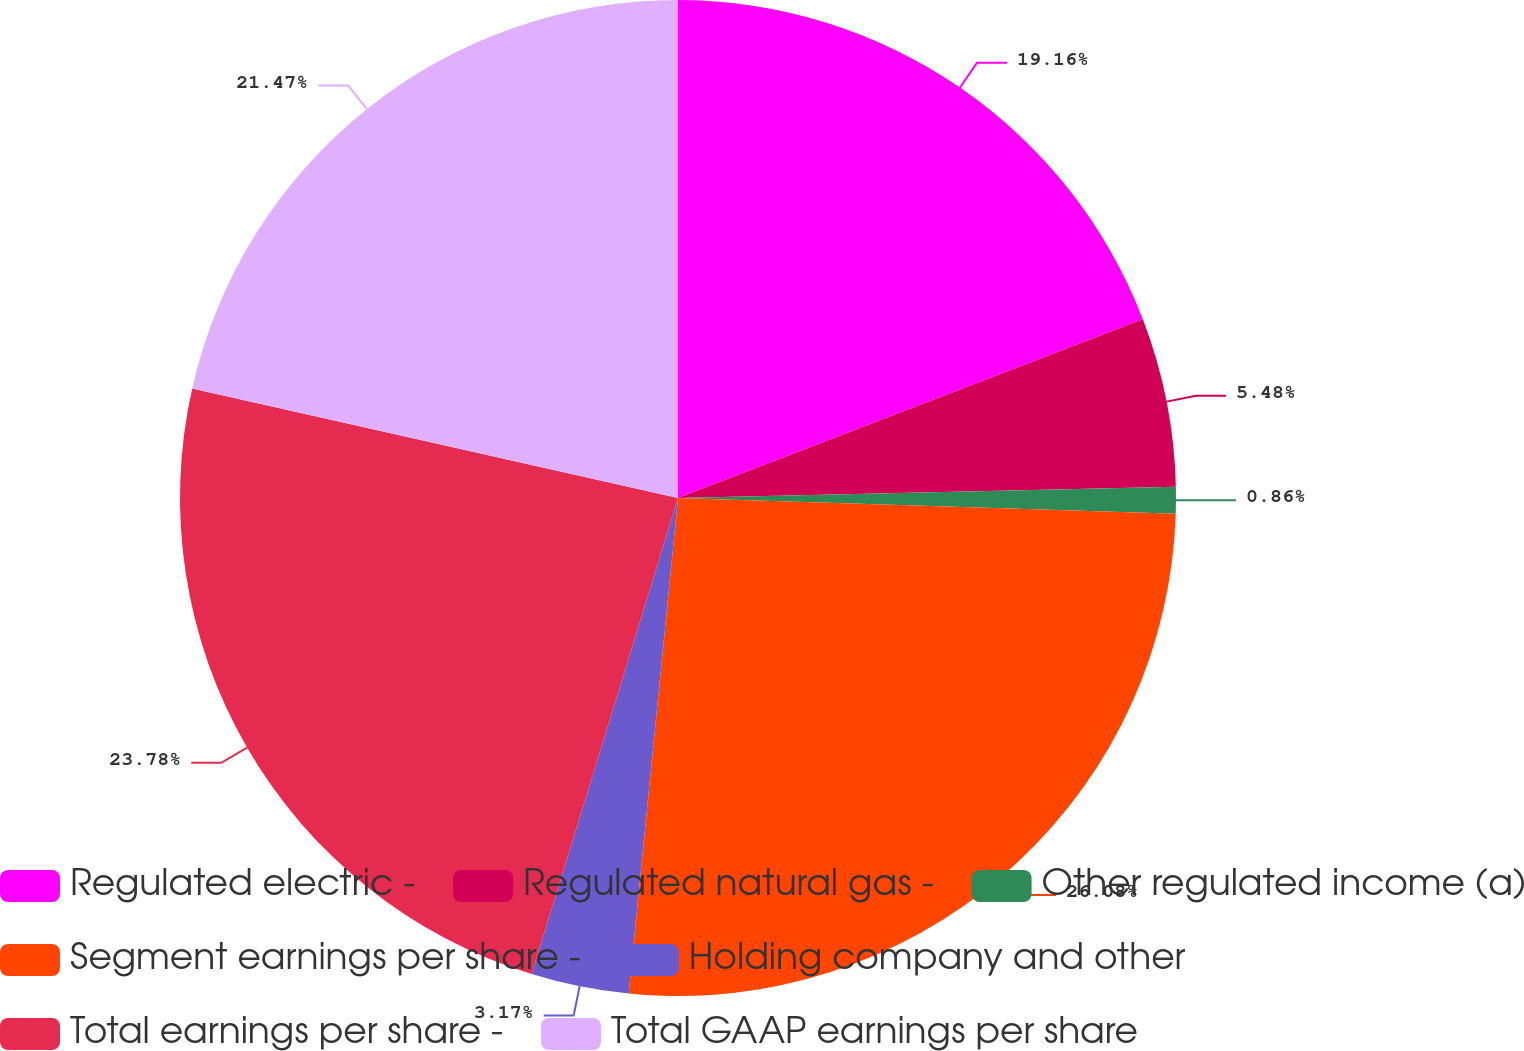<chart> <loc_0><loc_0><loc_500><loc_500><pie_chart><fcel>Regulated electric -<fcel>Regulated natural gas -<fcel>Other regulated income (a)<fcel>Segment earnings per share -<fcel>Holding company and other<fcel>Total earnings per share -<fcel>Total GAAP earnings per share<nl><fcel>19.16%<fcel>5.48%<fcel>0.86%<fcel>26.08%<fcel>3.17%<fcel>23.78%<fcel>21.47%<nl></chart> 